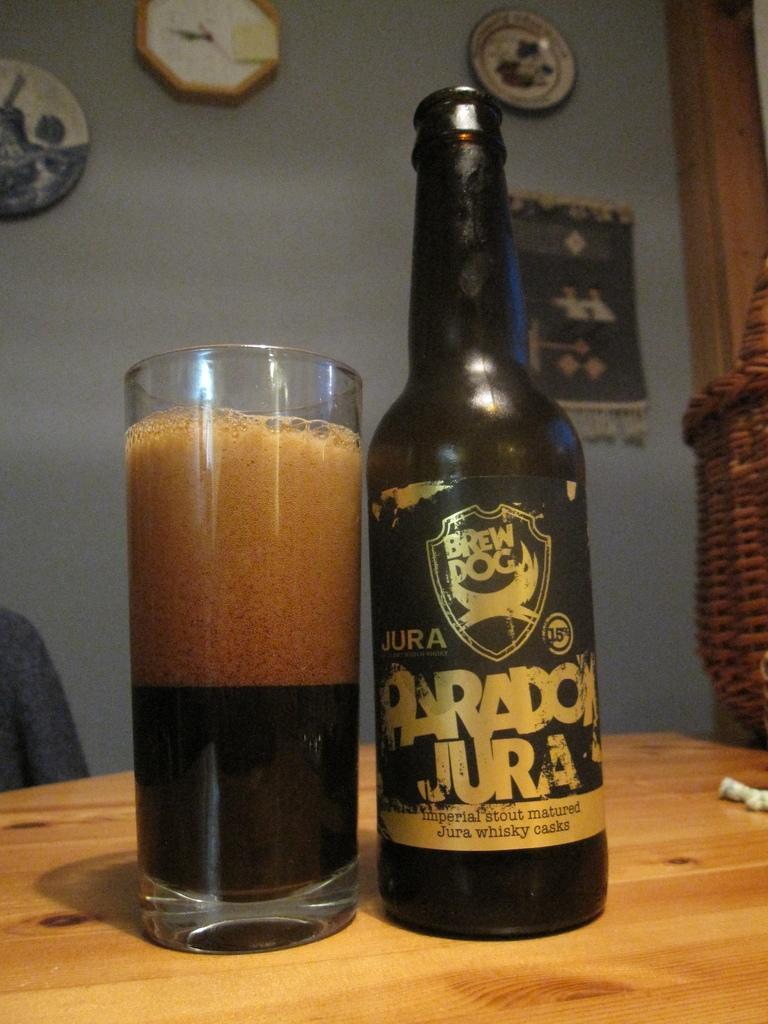Can you describe this image briefly? In this picture I can see e a bottle and a glass on the table and I can see a wall clock and couple of mementos and a cloth on the wall. 